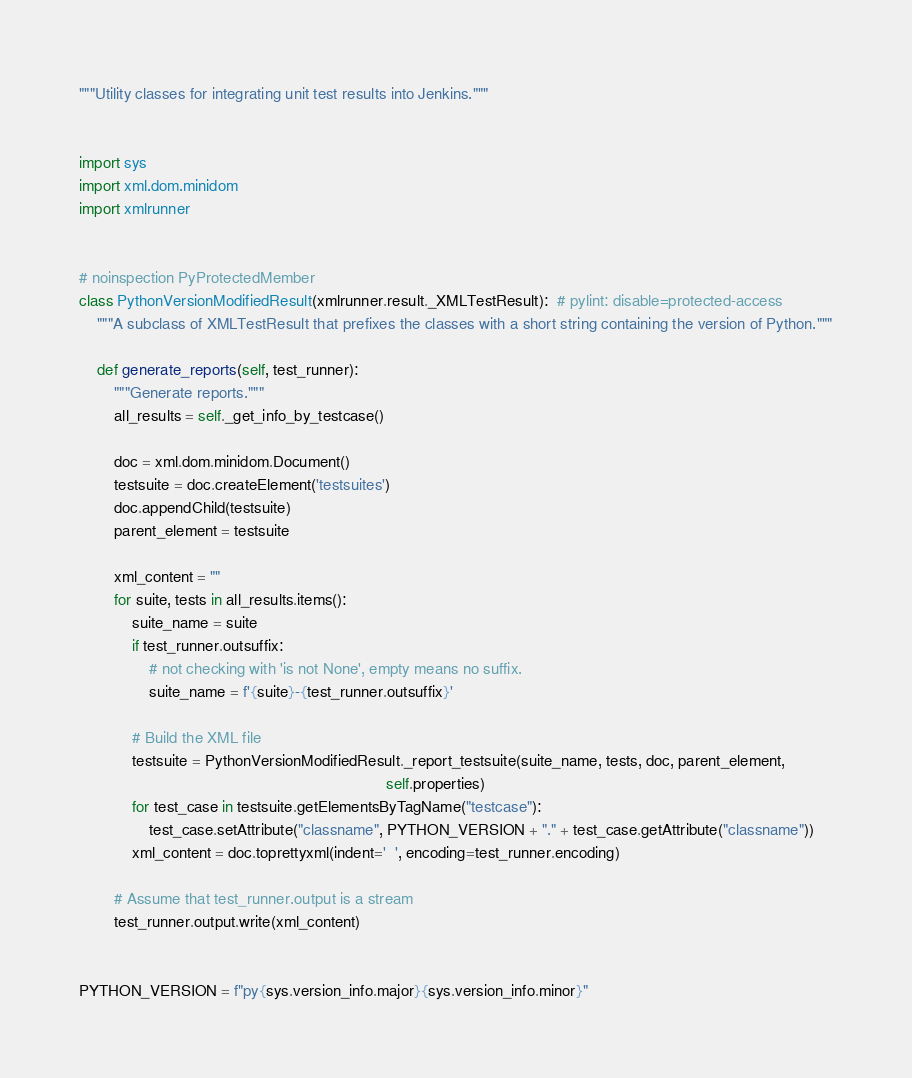Convert code to text. <code><loc_0><loc_0><loc_500><loc_500><_Python_>"""Utility classes for integrating unit test results into Jenkins."""


import sys
import xml.dom.minidom
import xmlrunner


# noinspection PyProtectedMember
class PythonVersionModifiedResult(xmlrunner.result._XMLTestResult):  # pylint: disable=protected-access
    """A subclass of XMLTestResult that prefixes the classes with a short string containing the version of Python."""

    def generate_reports(self, test_runner):
        """Generate reports."""
        all_results = self._get_info_by_testcase()

        doc = xml.dom.minidom.Document()
        testsuite = doc.createElement('testsuites')
        doc.appendChild(testsuite)
        parent_element = testsuite

        xml_content = ""
        for suite, tests in all_results.items():
            suite_name = suite
            if test_runner.outsuffix:
                # not checking with 'is not None', empty means no suffix.
                suite_name = f'{suite}-{test_runner.outsuffix}'

            # Build the XML file
            testsuite = PythonVersionModifiedResult._report_testsuite(suite_name, tests, doc, parent_element,
                                                                      self.properties)
            for test_case in testsuite.getElementsByTagName("testcase"):
                test_case.setAttribute("classname", PYTHON_VERSION + "." + test_case.getAttribute("classname"))
            xml_content = doc.toprettyxml(indent='  ', encoding=test_runner.encoding)

        # Assume that test_runner.output is a stream
        test_runner.output.write(xml_content)


PYTHON_VERSION = f"py{sys.version_info.major}{sys.version_info.minor}"
</code> 